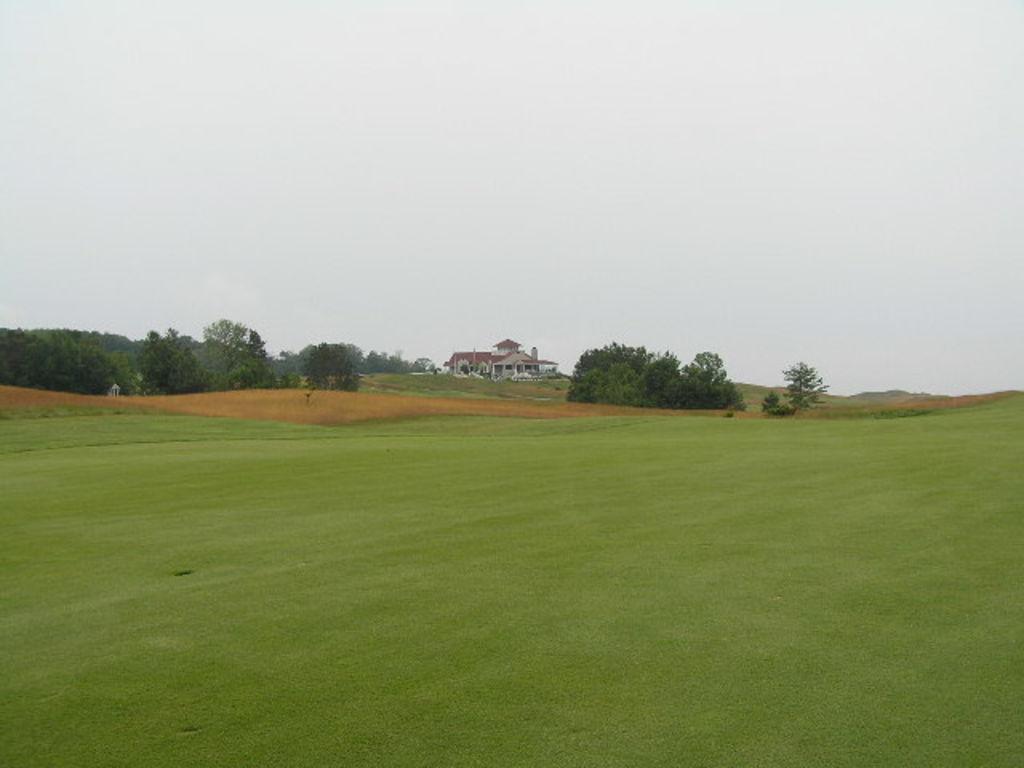Could you give a brief overview of what you see in this image? In this picture I can see the grass in front and in the middle of this picture I see few trees and a building. In the background I see the sky. 